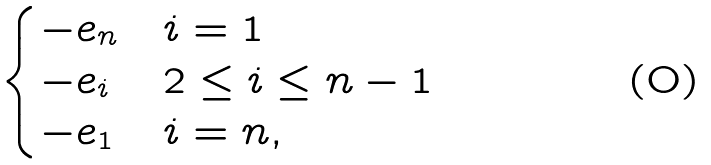Convert formula to latex. <formula><loc_0><loc_0><loc_500><loc_500>\begin{cases} - e _ { n } & i = 1 \\ - e _ { i } & 2 \leq i \leq n - 1 \\ - e _ { 1 } & i = n , \end{cases}</formula> 